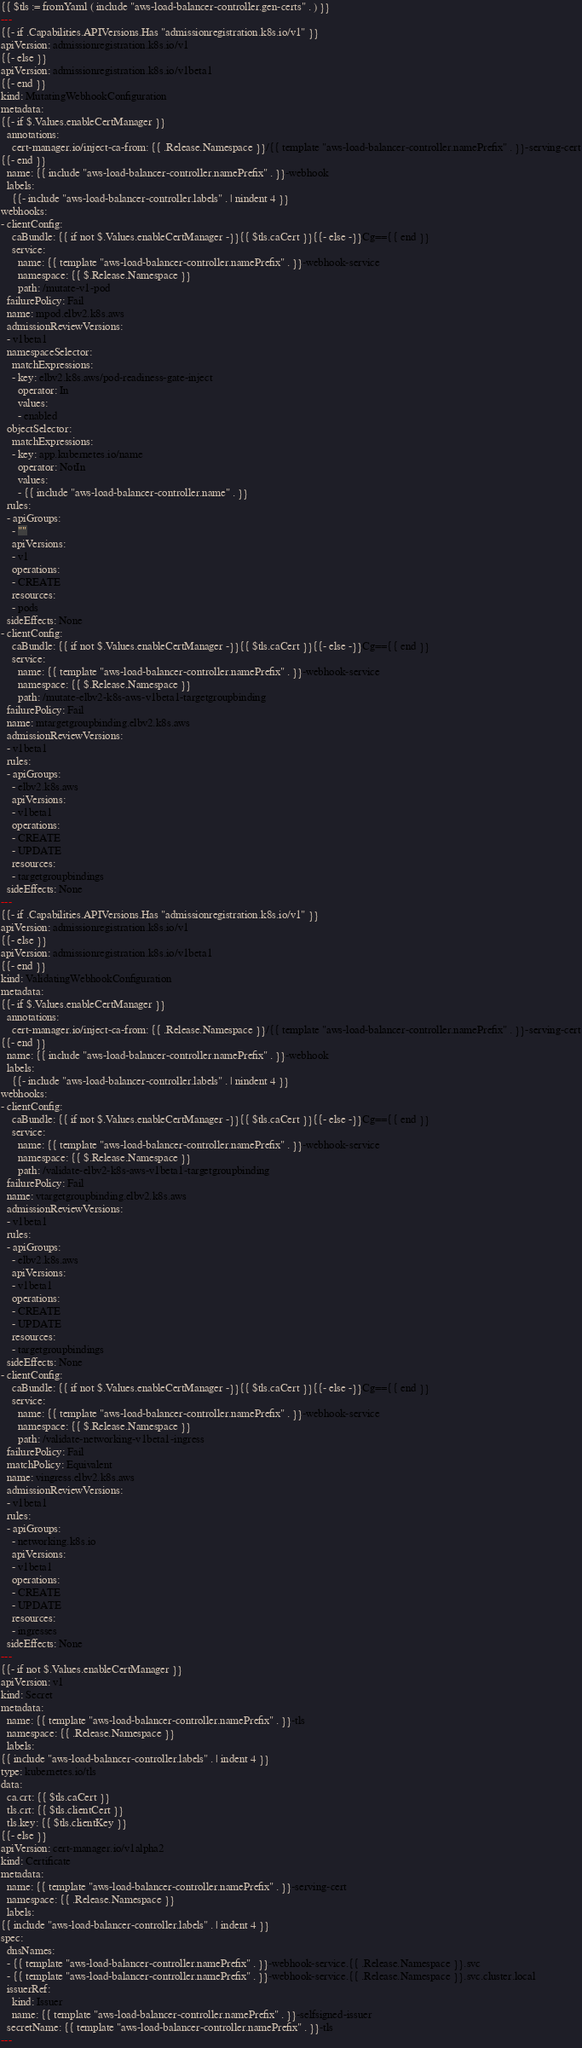<code> <loc_0><loc_0><loc_500><loc_500><_YAML_>{{ $tls := fromYaml ( include "aws-load-balancer-controller.gen-certs" . ) }}
---
{{- if .Capabilities.APIVersions.Has "admissionregistration.k8s.io/v1" }}
apiVersion: admissionregistration.k8s.io/v1
{{- else }}
apiVersion: admissionregistration.k8s.io/v1beta1
{{- end }}
kind: MutatingWebhookConfiguration
metadata:
{{- if $.Values.enableCertManager }}
  annotations:
    cert-manager.io/inject-ca-from: {{ .Release.Namespace }}/{{ template "aws-load-balancer-controller.namePrefix" . }}-serving-cert
{{- end }}
  name: {{ include "aws-load-balancer-controller.namePrefix" . }}-webhook
  labels:
    {{- include "aws-load-balancer-controller.labels" . | nindent 4 }}
webhooks:
- clientConfig:
    caBundle: {{ if not $.Values.enableCertManager -}}{{ $tls.caCert }}{{- else -}}Cg=={{ end }}
    service:
      name: {{ template "aws-load-balancer-controller.namePrefix" . }}-webhook-service
      namespace: {{ $.Release.Namespace }}
      path: /mutate-v1-pod
  failurePolicy: Fail
  name: mpod.elbv2.k8s.aws
  admissionReviewVersions:
  - v1beta1
  namespaceSelector:
    matchExpressions:
    - key: elbv2.k8s.aws/pod-readiness-gate-inject
      operator: In
      values:
      - enabled
  objectSelector:
    matchExpressions:
    - key: app.kubernetes.io/name
      operator: NotIn
      values:
      - {{ include "aws-load-balancer-controller.name" . }}
  rules:
  - apiGroups:
    - ""
    apiVersions:
    - v1
    operations:
    - CREATE
    resources:
    - pods
  sideEffects: None
- clientConfig:
    caBundle: {{ if not $.Values.enableCertManager -}}{{ $tls.caCert }}{{- else -}}Cg=={{ end }}
    service:
      name: {{ template "aws-load-balancer-controller.namePrefix" . }}-webhook-service
      namespace: {{ $.Release.Namespace }}
      path: /mutate-elbv2-k8s-aws-v1beta1-targetgroupbinding
  failurePolicy: Fail
  name: mtargetgroupbinding.elbv2.k8s.aws
  admissionReviewVersions:
  - v1beta1
  rules:
  - apiGroups:
    - elbv2.k8s.aws
    apiVersions:
    - v1beta1
    operations:
    - CREATE
    - UPDATE
    resources:
    - targetgroupbindings
  sideEffects: None
---
{{- if .Capabilities.APIVersions.Has "admissionregistration.k8s.io/v1" }}
apiVersion: admissionregistration.k8s.io/v1
{{- else }}
apiVersion: admissionregistration.k8s.io/v1beta1
{{- end }}
kind: ValidatingWebhookConfiguration
metadata:
{{- if $.Values.enableCertManager }}
  annotations:
    cert-manager.io/inject-ca-from: {{ .Release.Namespace }}/{{ template "aws-load-balancer-controller.namePrefix" . }}-serving-cert
{{- end }}
  name: {{ include "aws-load-balancer-controller.namePrefix" . }}-webhook
  labels:
    {{- include "aws-load-balancer-controller.labels" . | nindent 4 }}
webhooks:
- clientConfig:
    caBundle: {{ if not $.Values.enableCertManager -}}{{ $tls.caCert }}{{- else -}}Cg=={{ end }}
    service:
      name: {{ template "aws-load-balancer-controller.namePrefix" . }}-webhook-service
      namespace: {{ $.Release.Namespace }}
      path: /validate-elbv2-k8s-aws-v1beta1-targetgroupbinding
  failurePolicy: Fail
  name: vtargetgroupbinding.elbv2.k8s.aws
  admissionReviewVersions:
  - v1beta1
  rules:
  - apiGroups:
    - elbv2.k8s.aws
    apiVersions:
    - v1beta1
    operations:
    - CREATE
    - UPDATE
    resources:
    - targetgroupbindings
  sideEffects: None
- clientConfig:
    caBundle: {{ if not $.Values.enableCertManager -}}{{ $tls.caCert }}{{- else -}}Cg=={{ end }}
    service:
      name: {{ template "aws-load-balancer-controller.namePrefix" . }}-webhook-service
      namespace: {{ $.Release.Namespace }}
      path: /validate-networking-v1beta1-ingress
  failurePolicy: Fail
  matchPolicy: Equivalent
  name: vingress.elbv2.k8s.aws
  admissionReviewVersions:
  - v1beta1
  rules:
  - apiGroups:
    - networking.k8s.io
    apiVersions:
    - v1beta1
    operations:
    - CREATE
    - UPDATE
    resources:
    - ingresses
  sideEffects: None
---
{{- if not $.Values.enableCertManager }}
apiVersion: v1
kind: Secret
metadata:
  name: {{ template "aws-load-balancer-controller.namePrefix" . }}-tls
  namespace: {{ .Release.Namespace }}
  labels:
{{ include "aws-load-balancer-controller.labels" . | indent 4 }}
type: kubernetes.io/tls
data:
  ca.crt: {{ $tls.caCert }}
  tls.crt: {{ $tls.clientCert }}
  tls.key: {{ $tls.clientKey }}
{{- else }}
apiVersion: cert-manager.io/v1alpha2
kind: Certificate
metadata:
  name: {{ template "aws-load-balancer-controller.namePrefix" . }}-serving-cert
  namespace: {{ .Release.Namespace }}
  labels:
{{ include "aws-load-balancer-controller.labels" . | indent 4 }}
spec:
  dnsNames:
  - {{ template "aws-load-balancer-controller.namePrefix" . }}-webhook-service.{{ .Release.Namespace }}.svc
  - {{ template "aws-load-balancer-controller.namePrefix" . }}-webhook-service.{{ .Release.Namespace }}.svc.cluster.local
  issuerRef:
    kind: Issuer
    name: {{ template "aws-load-balancer-controller.namePrefix" . }}-selfsigned-issuer
  secretName: {{ template "aws-load-balancer-controller.namePrefix" . }}-tls
---</code> 